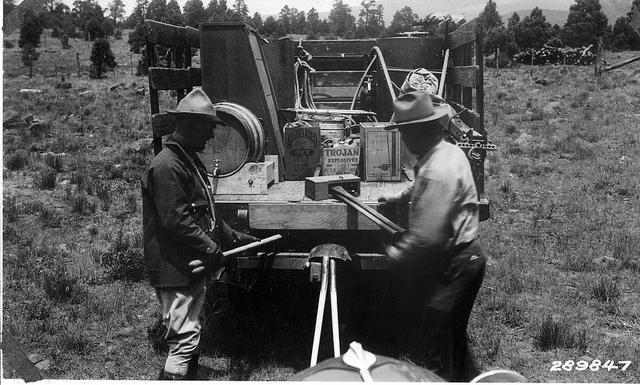How many people are there?
Give a very brief answer. 2. How many dogs are in this picture?
Give a very brief answer. 0. 